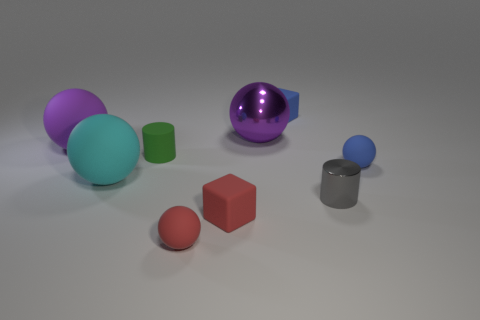Does the tiny blue cube have the same material as the blue ball?
Keep it short and to the point. Yes. How many other objects are the same size as the green cylinder?
Your answer should be very brief. 5. There is a small gray cylinder; what number of red rubber blocks are to the right of it?
Your response must be concise. 0. Is the number of small green objects that are behind the large purple shiny ball the same as the number of things that are right of the small green matte object?
Your answer should be compact. No. What size is the cyan thing that is the same shape as the purple metallic thing?
Your answer should be compact. Large. There is a purple thing to the left of the small matte cylinder; what is its shape?
Ensure brevity in your answer.  Sphere. Are the small ball right of the big metallic sphere and the purple object that is to the right of the tiny red cube made of the same material?
Give a very brief answer. No. What shape is the large shiny object?
Your answer should be very brief. Sphere. Are there the same number of big cyan objects that are behind the cyan rubber thing and big green cylinders?
Ensure brevity in your answer.  Yes. Are there any green cylinders made of the same material as the gray object?
Your answer should be very brief. No. 